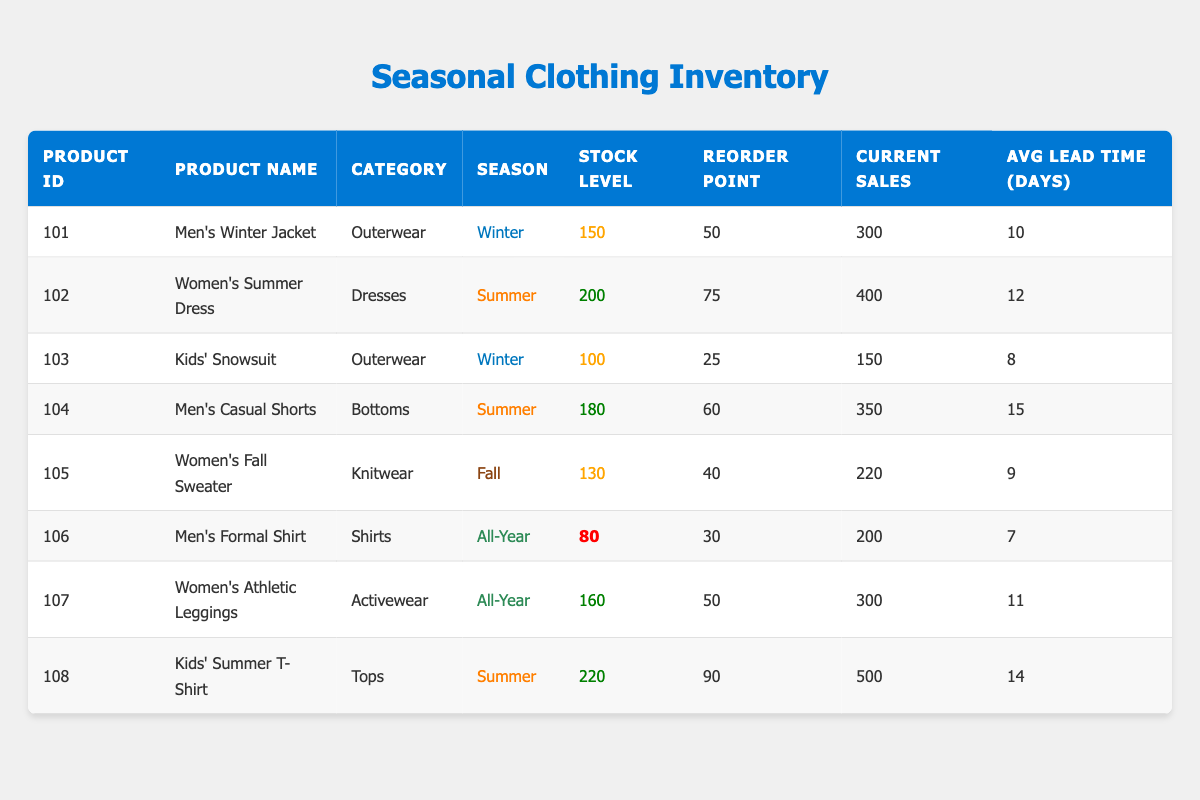What is the stock level for Women's Summer Dress? The stock level for Women's Summer Dress is directly provided in the table under the "Stock Level" column next to the corresponding product listing. The value is 200.
Answer: 200 What is the reorder point for Men's Casual Shorts? The reorder point can be found in the same row as Men's Casual Shorts under the "Reorder Point" column. The value is 60.
Answer: 60 How many products have a stock level below 100? To find this, I need to check the "Stock Level" for each product. There's one product with a stock level below 100: Men's Formal Shirt (80). Thus, the total count is 1.
Answer: 1 Which product has the highest current sales? In the "Current Sales" column, I compare all values. The highest current sales figure is 500 for Kids' Summer T-Shirt.
Answer: Kids' Summer T-Shirt What is the average stock level for summer products? To calculate this, I first identify all summer products: Women's Summer Dress (200), Men's Casual Shorts (180), and Kids' Summer T-Shirt (220). The total stock levels for these products are 200 + 180 + 220 = 600. There are 3 summer products, so the average is 600 / 3 = 200.
Answer: 200 Is the stock level for Men's Winter Jacket above its reorder point? I compare the stock level of Men's Winter Jacket (150) with its reorder point (50). Since 150 is greater than 50, the statement is true.
Answer: Yes What is the total current sales for all winter products? I need to identify winter products from the table: Men's Winter Jacket (300) and Kids' Snowsuit (150). The total current sales are calculated by summing their current sales: 300 + 150 = 450.
Answer: 450 Does any product in the table have a stock level of exactly 130? I can check the "Stock Level" column for the value of 130. There is a product, Women's Fall Sweater, with a stock level of 130, making the statement true.
Answer: Yes What is the difference between the stock level of Kids' Snowsuit and the reorder point? First, I check the stock level of Kids' Snowsuit, which is 100, and its reorder point, which is 25. The difference is calculated as 100 - 25 = 75.
Answer: 75 